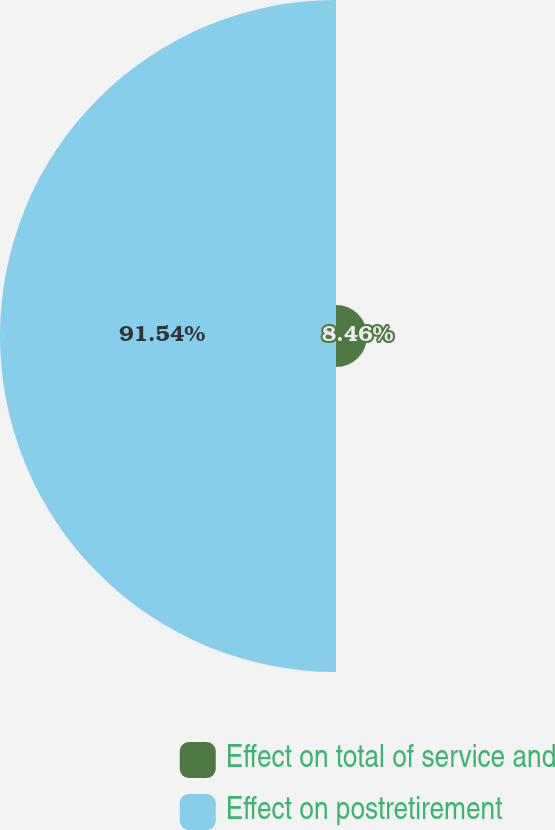Convert chart. <chart><loc_0><loc_0><loc_500><loc_500><pie_chart><fcel>Effect on total of service and<fcel>Effect on postretirement<nl><fcel>8.46%<fcel>91.54%<nl></chart> 